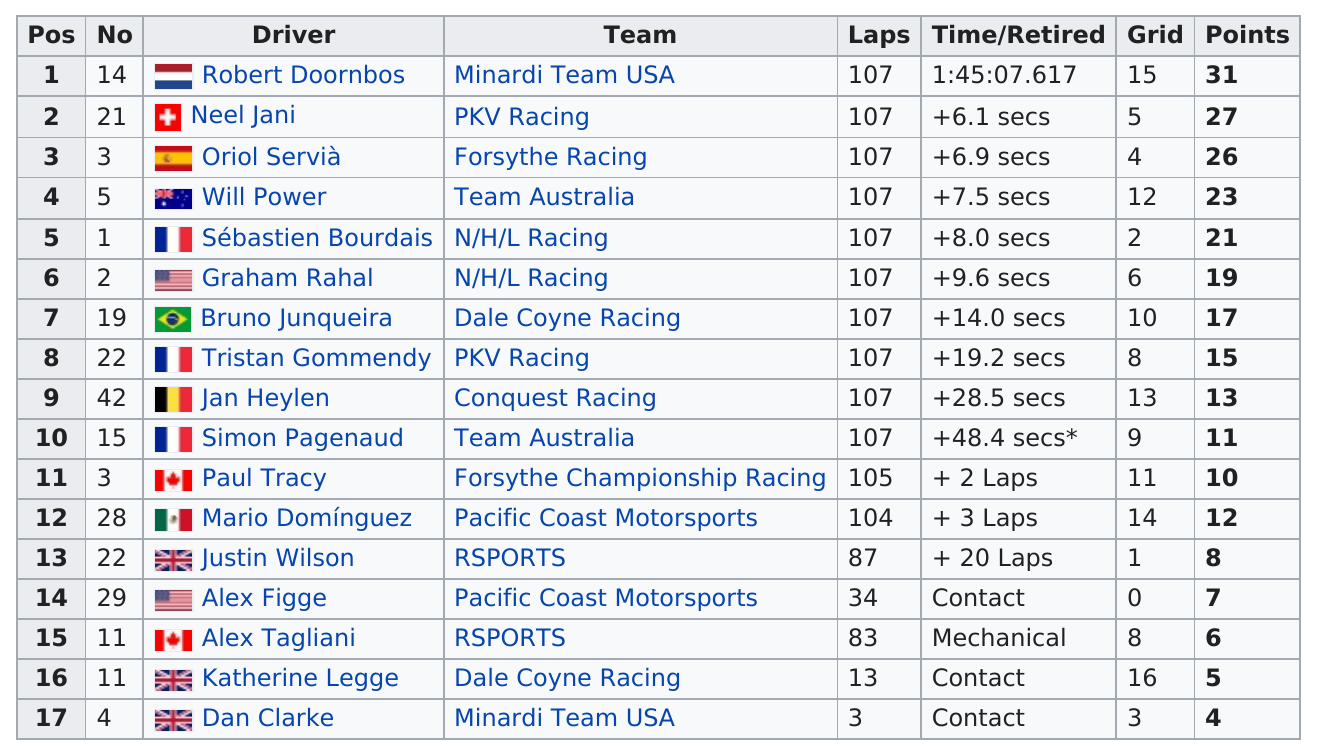Indicate a few pertinent items in this graphic. Four drivers did not finish the race. The total time for the race for Robert Doornbos was 1 hour and 45 minutes and 7.617 seconds. The name of the driver in the last position is Dan Clarke. Robert Doornbos finished before Neel Jani. The top team was Minardi Team USA. 